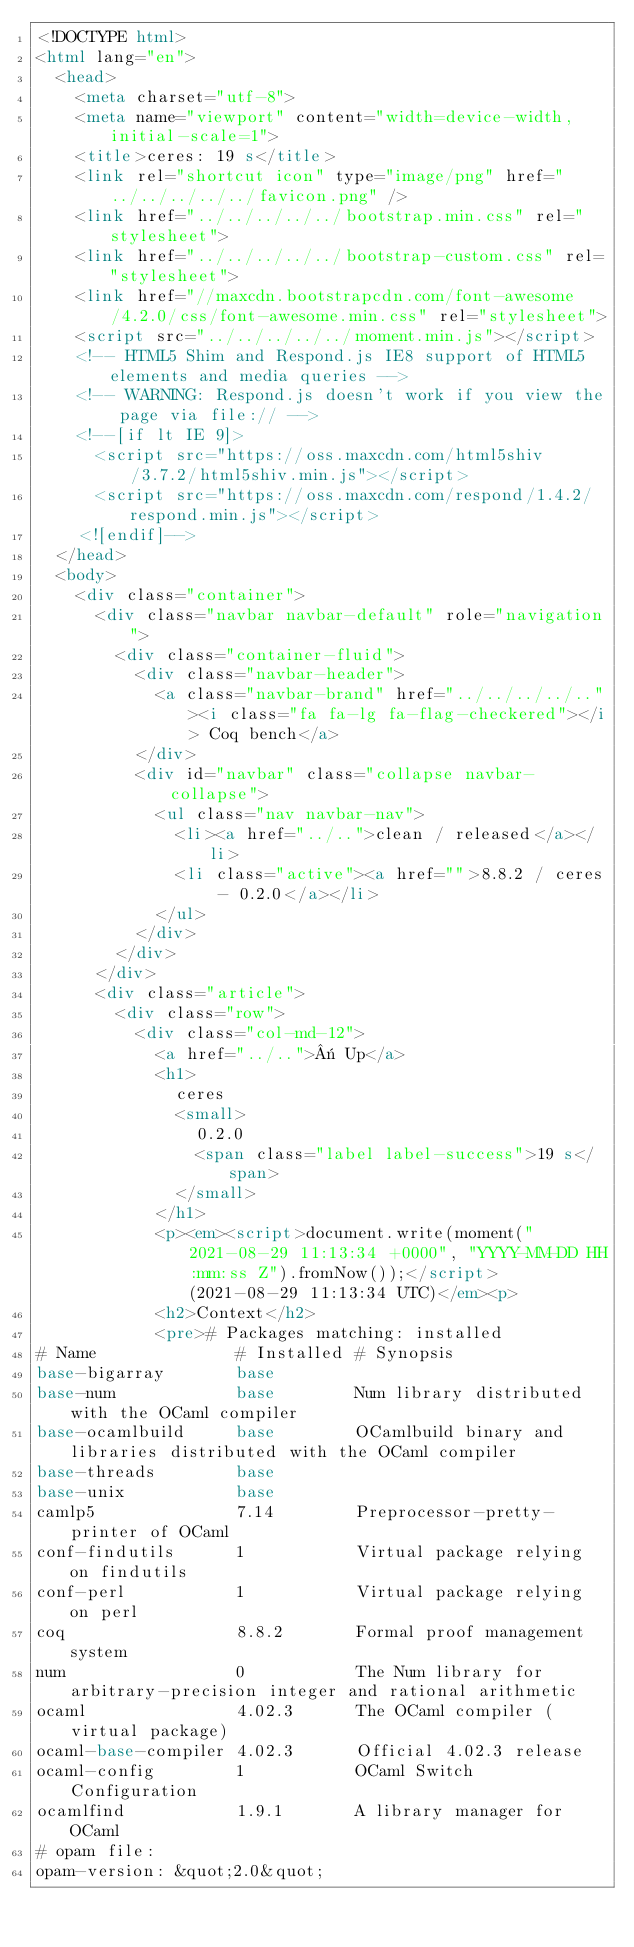Convert code to text. <code><loc_0><loc_0><loc_500><loc_500><_HTML_><!DOCTYPE html>
<html lang="en">
  <head>
    <meta charset="utf-8">
    <meta name="viewport" content="width=device-width, initial-scale=1">
    <title>ceres: 19 s</title>
    <link rel="shortcut icon" type="image/png" href="../../../../../favicon.png" />
    <link href="../../../../../bootstrap.min.css" rel="stylesheet">
    <link href="../../../../../bootstrap-custom.css" rel="stylesheet">
    <link href="//maxcdn.bootstrapcdn.com/font-awesome/4.2.0/css/font-awesome.min.css" rel="stylesheet">
    <script src="../../../../../moment.min.js"></script>
    <!-- HTML5 Shim and Respond.js IE8 support of HTML5 elements and media queries -->
    <!-- WARNING: Respond.js doesn't work if you view the page via file:// -->
    <!--[if lt IE 9]>
      <script src="https://oss.maxcdn.com/html5shiv/3.7.2/html5shiv.min.js"></script>
      <script src="https://oss.maxcdn.com/respond/1.4.2/respond.min.js"></script>
    <![endif]-->
  </head>
  <body>
    <div class="container">
      <div class="navbar navbar-default" role="navigation">
        <div class="container-fluid">
          <div class="navbar-header">
            <a class="navbar-brand" href="../../../../.."><i class="fa fa-lg fa-flag-checkered"></i> Coq bench</a>
          </div>
          <div id="navbar" class="collapse navbar-collapse">
            <ul class="nav navbar-nav">
              <li><a href="../..">clean / released</a></li>
              <li class="active"><a href="">8.8.2 / ceres - 0.2.0</a></li>
            </ul>
          </div>
        </div>
      </div>
      <div class="article">
        <div class="row">
          <div class="col-md-12">
            <a href="../..">« Up</a>
            <h1>
              ceres
              <small>
                0.2.0
                <span class="label label-success">19 s</span>
              </small>
            </h1>
            <p><em><script>document.write(moment("2021-08-29 11:13:34 +0000", "YYYY-MM-DD HH:mm:ss Z").fromNow());</script> (2021-08-29 11:13:34 UTC)</em><p>
            <h2>Context</h2>
            <pre># Packages matching: installed
# Name              # Installed # Synopsis
base-bigarray       base
base-num            base        Num library distributed with the OCaml compiler
base-ocamlbuild     base        OCamlbuild binary and libraries distributed with the OCaml compiler
base-threads        base
base-unix           base
camlp5              7.14        Preprocessor-pretty-printer of OCaml
conf-findutils      1           Virtual package relying on findutils
conf-perl           1           Virtual package relying on perl
coq                 8.8.2       Formal proof management system
num                 0           The Num library for arbitrary-precision integer and rational arithmetic
ocaml               4.02.3      The OCaml compiler (virtual package)
ocaml-base-compiler 4.02.3      Official 4.02.3 release
ocaml-config        1           OCaml Switch Configuration
ocamlfind           1.9.1       A library manager for OCaml
# opam file:
opam-version: &quot;2.0&quot;</code> 